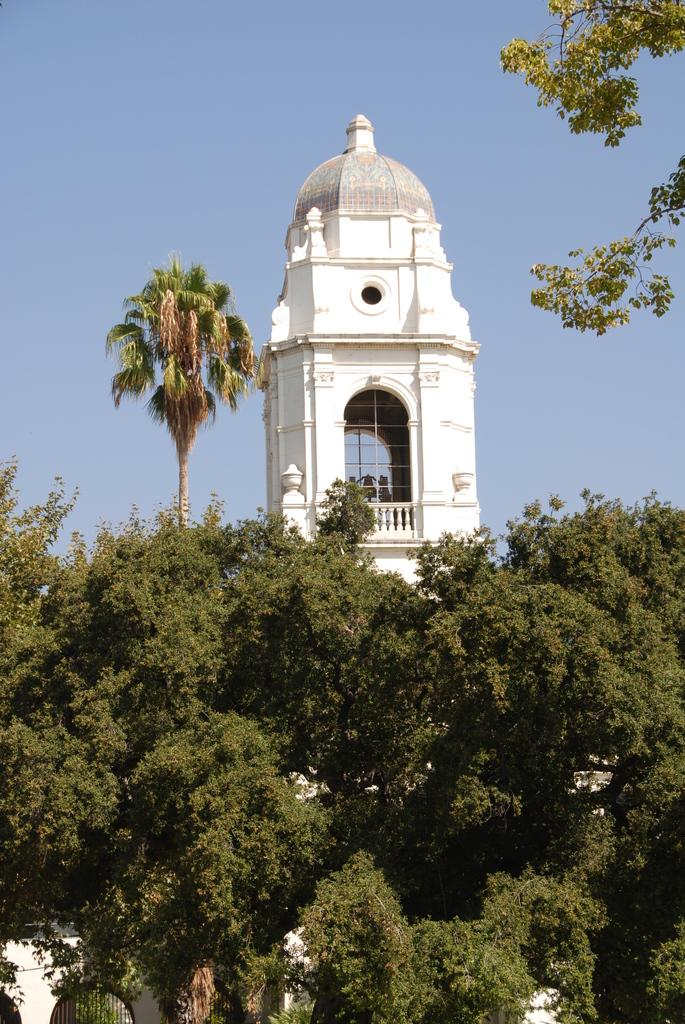Where was the picture taken? The picture was clicked outside. What can be seen in the foreground of the image? There are trees and a building in the foreground of the image. What is the main subject in the center of the image? There is a tower in the center of the image. What is visible in the background of the image? The sky is visible in the background of the image. Can you see a robin perched on the tower in the image? There is no robin present in the image. Is the ornament on the building in the image made of gold? There is no ornament mentioned or visible on the building in the image. 